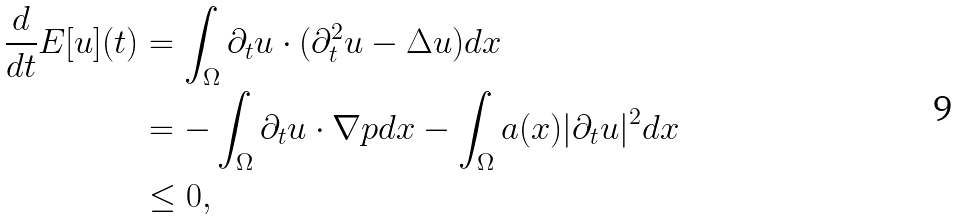Convert formula to latex. <formula><loc_0><loc_0><loc_500><loc_500>\frac { d } { d t } E [ u ] ( t ) & = \int _ { \Omega } \partial _ { t } u \cdot ( \partial _ { t } ^ { 2 } u - \Delta u ) d x \\ & = - \int _ { \Omega } \partial _ { t } u \cdot \nabla p d x - \int _ { \Omega } a ( x ) | \partial _ { t } u | ^ { 2 } d x \\ & \leq 0 ,</formula> 